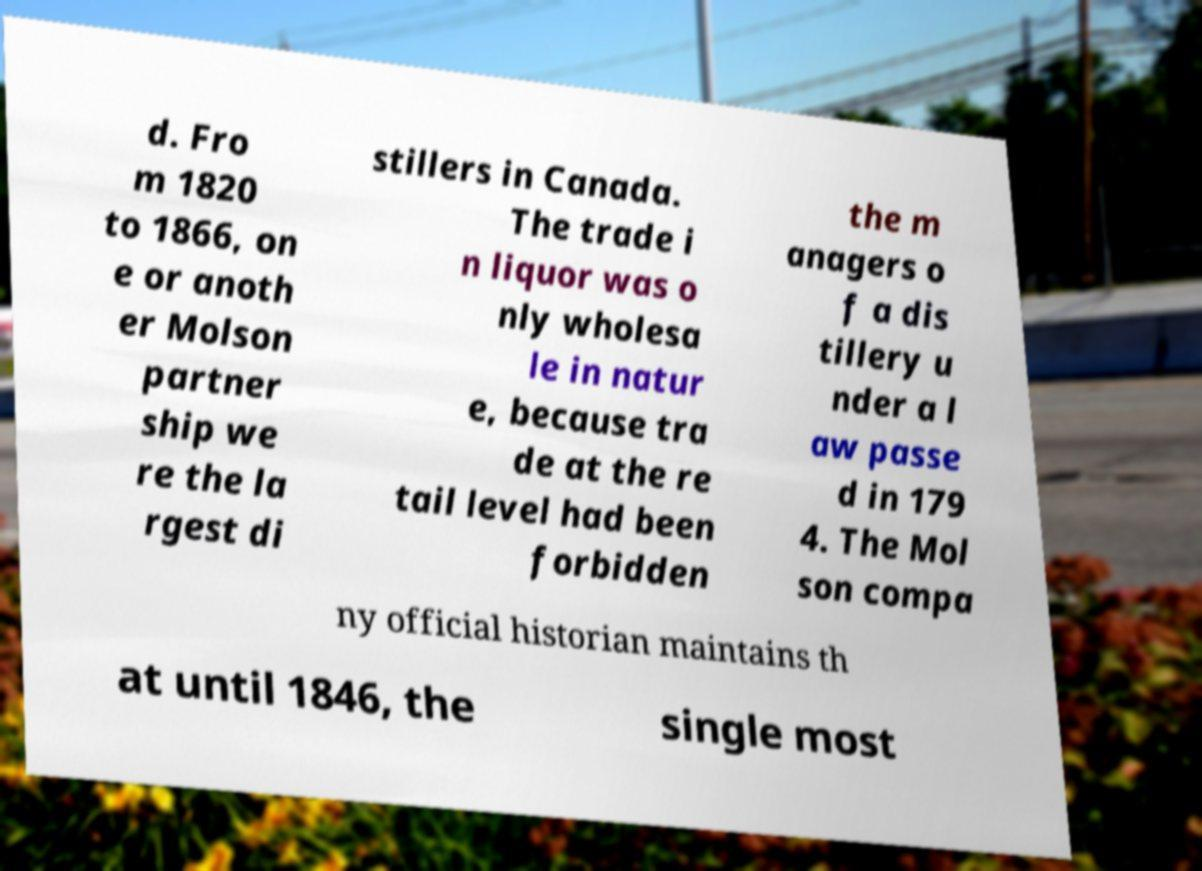I need the written content from this picture converted into text. Can you do that? d. Fro m 1820 to 1866, on e or anoth er Molson partner ship we re the la rgest di stillers in Canada. The trade i n liquor was o nly wholesa le in natur e, because tra de at the re tail level had been forbidden the m anagers o f a dis tillery u nder a l aw passe d in 179 4. The Mol son compa ny official historian maintains th at until 1846, the single most 